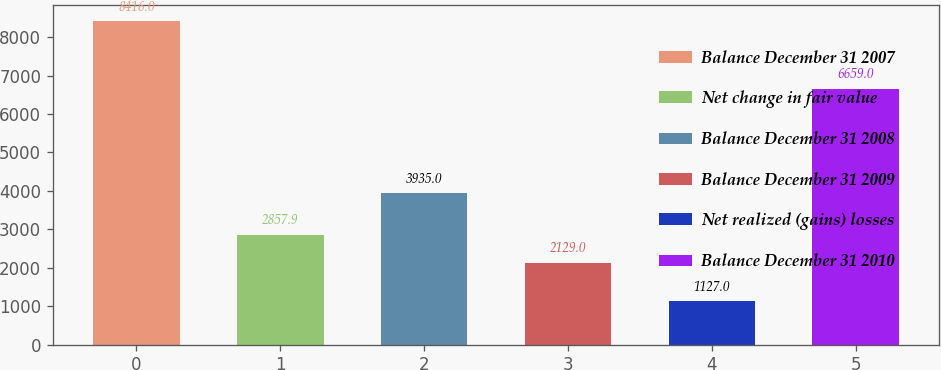Convert chart. <chart><loc_0><loc_0><loc_500><loc_500><bar_chart><fcel>Balance December 31 2007<fcel>Net change in fair value<fcel>Balance December 31 2008<fcel>Balance December 31 2009<fcel>Net realized (gains) losses<fcel>Balance December 31 2010<nl><fcel>8416<fcel>2857.9<fcel>3935<fcel>2129<fcel>1127<fcel>6659<nl></chart> 